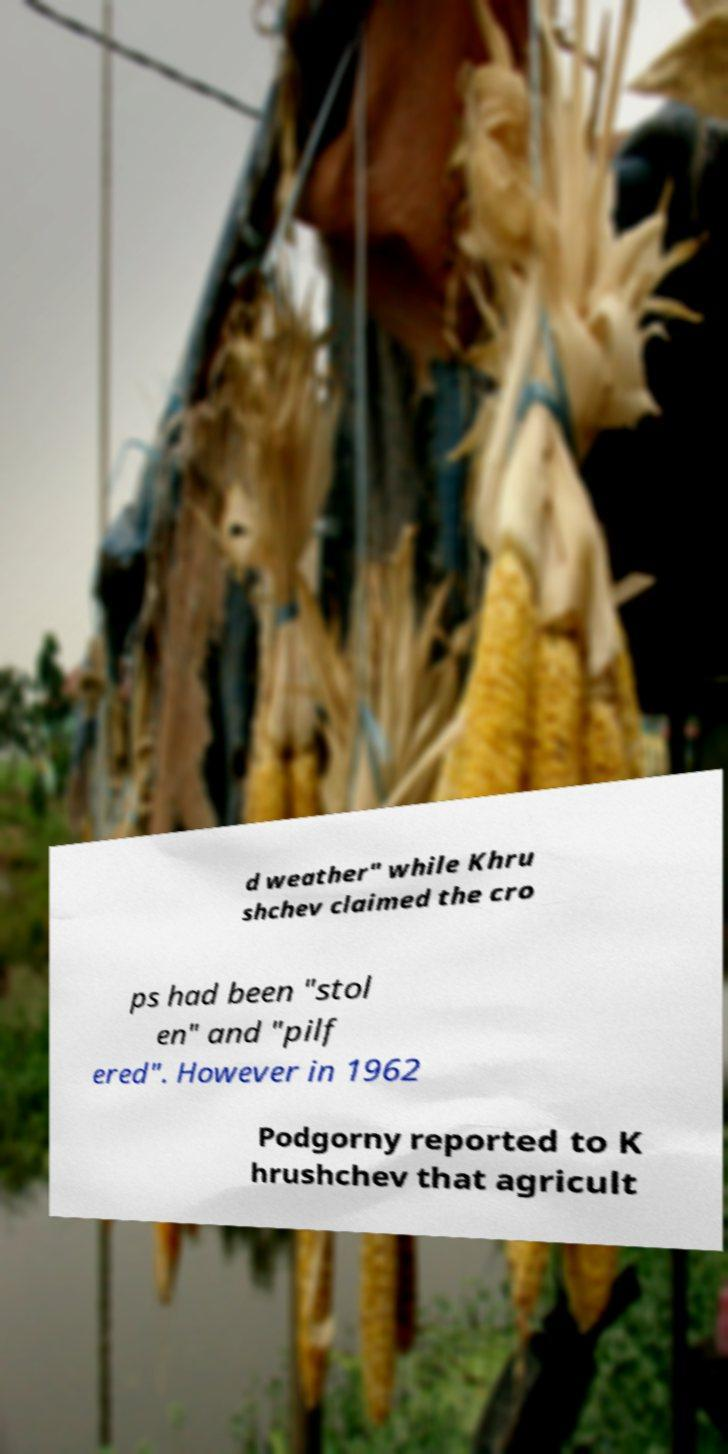I need the written content from this picture converted into text. Can you do that? d weather" while Khru shchev claimed the cro ps had been "stol en" and "pilf ered". However in 1962 Podgorny reported to K hrushchev that agricult 